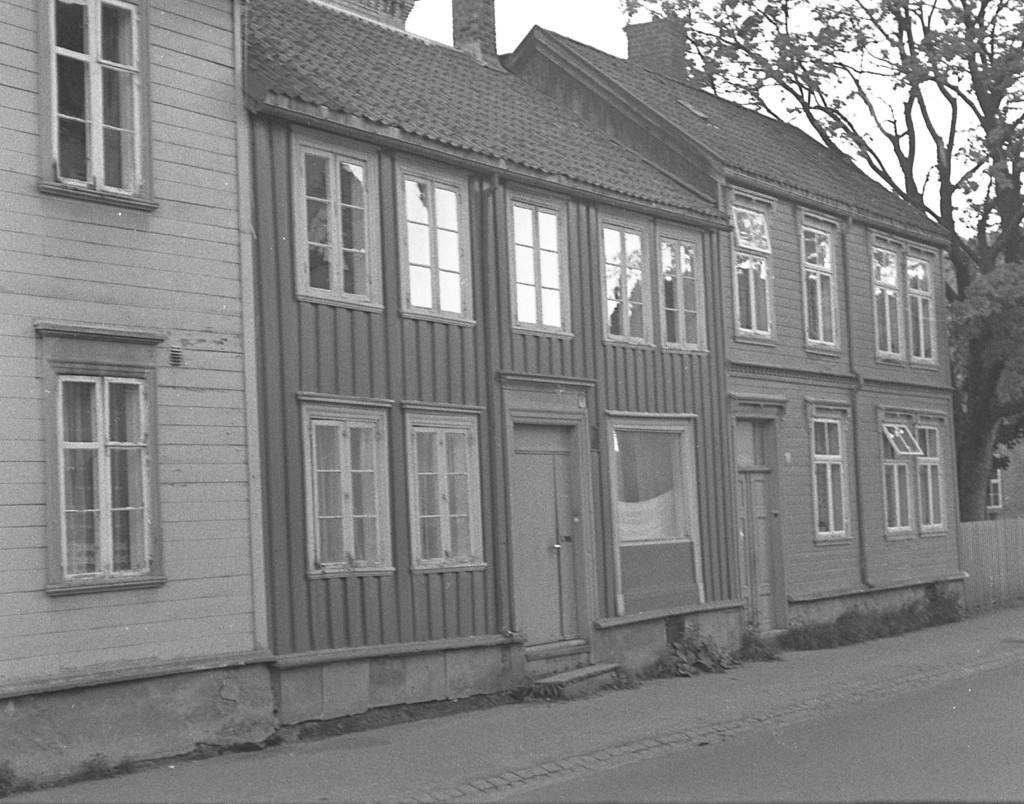Please provide a concise description of this image. On the right side, there is a road. Beside this road, there is a footpath. In the background, there is a building, which is having glass windows and roof. In the background, there is a tree, there is another building and there are clouds in the sky. 